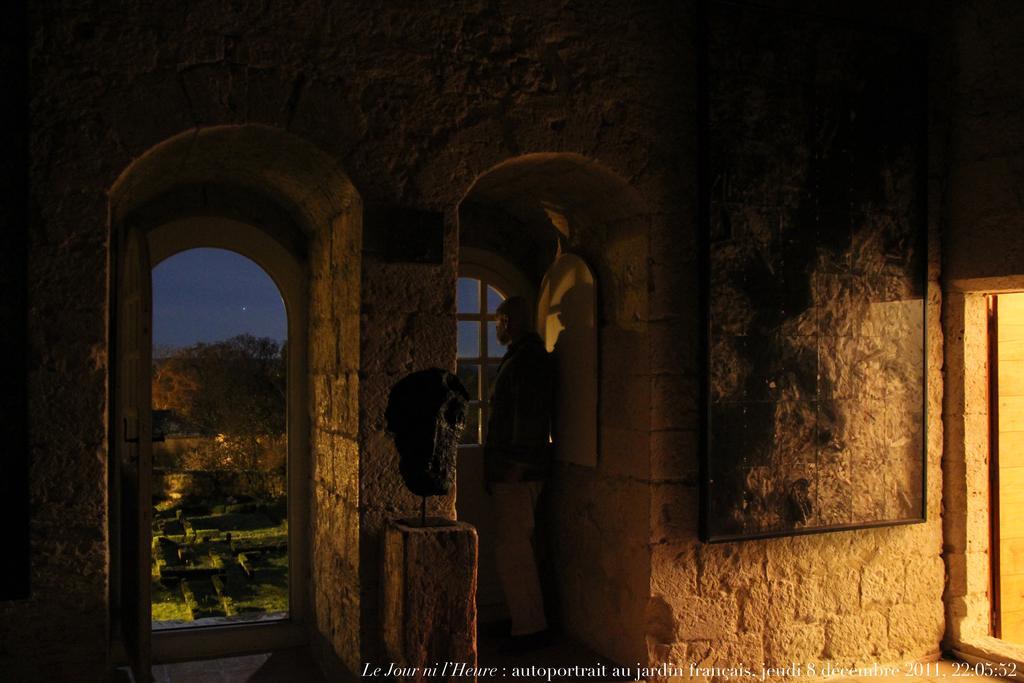Please provide a concise description of this image. On the bottom right, there is a watermark. In the background, there is a photo frame attached to a wall of a building, there is a person standing, there is a garden, there are trees and there is sky. 